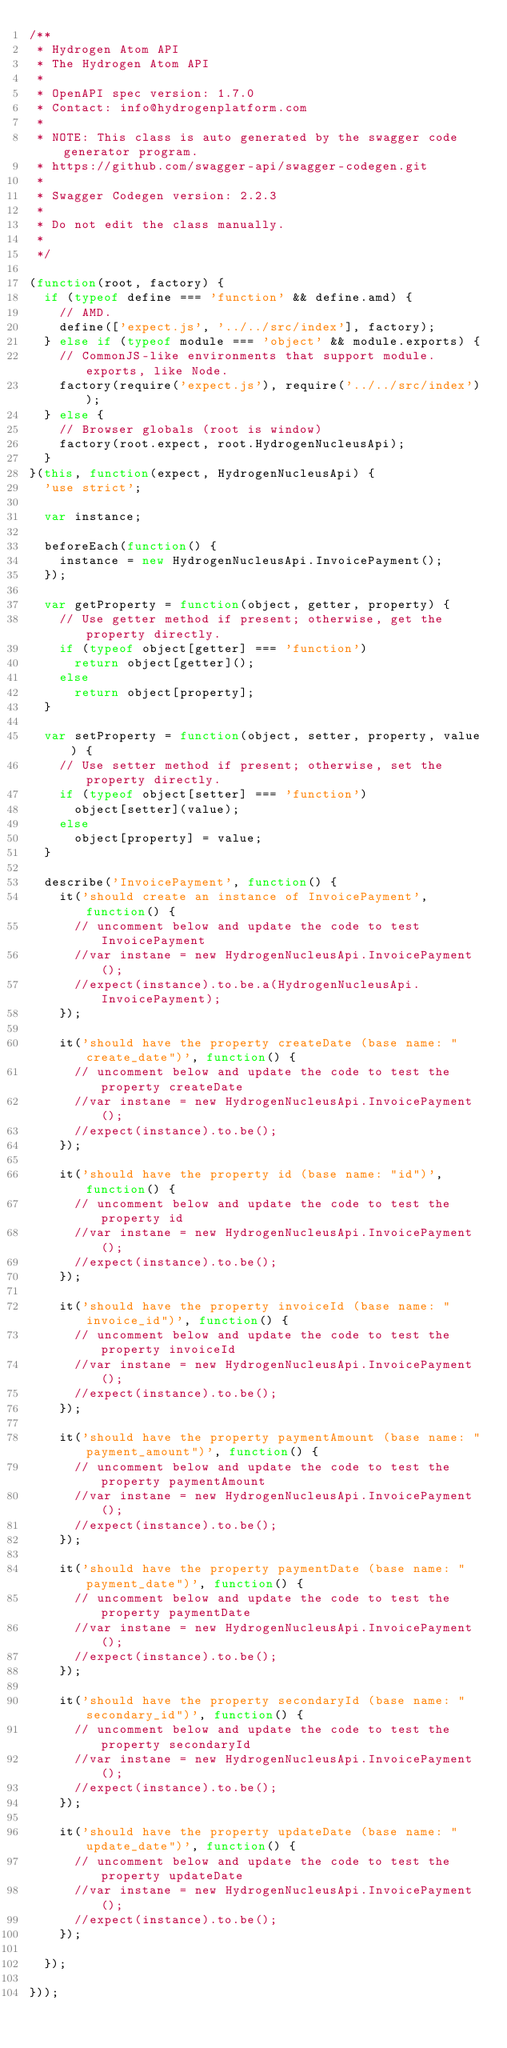<code> <loc_0><loc_0><loc_500><loc_500><_JavaScript_>/**
 * Hydrogen Atom API
 * The Hydrogen Atom API
 *
 * OpenAPI spec version: 1.7.0
 * Contact: info@hydrogenplatform.com
 *
 * NOTE: This class is auto generated by the swagger code generator program.
 * https://github.com/swagger-api/swagger-codegen.git
 *
 * Swagger Codegen version: 2.2.3
 *
 * Do not edit the class manually.
 *
 */

(function(root, factory) {
  if (typeof define === 'function' && define.amd) {
    // AMD.
    define(['expect.js', '../../src/index'], factory);
  } else if (typeof module === 'object' && module.exports) {
    // CommonJS-like environments that support module.exports, like Node.
    factory(require('expect.js'), require('../../src/index'));
  } else {
    // Browser globals (root is window)
    factory(root.expect, root.HydrogenNucleusApi);
  }
}(this, function(expect, HydrogenNucleusApi) {
  'use strict';

  var instance;

  beforeEach(function() {
    instance = new HydrogenNucleusApi.InvoicePayment();
  });

  var getProperty = function(object, getter, property) {
    // Use getter method if present; otherwise, get the property directly.
    if (typeof object[getter] === 'function')
      return object[getter]();
    else
      return object[property];
  }

  var setProperty = function(object, setter, property, value) {
    // Use setter method if present; otherwise, set the property directly.
    if (typeof object[setter] === 'function')
      object[setter](value);
    else
      object[property] = value;
  }

  describe('InvoicePayment', function() {
    it('should create an instance of InvoicePayment', function() {
      // uncomment below and update the code to test InvoicePayment
      //var instane = new HydrogenNucleusApi.InvoicePayment();
      //expect(instance).to.be.a(HydrogenNucleusApi.InvoicePayment);
    });

    it('should have the property createDate (base name: "create_date")', function() {
      // uncomment below and update the code to test the property createDate
      //var instane = new HydrogenNucleusApi.InvoicePayment();
      //expect(instance).to.be();
    });

    it('should have the property id (base name: "id")', function() {
      // uncomment below and update the code to test the property id
      //var instane = new HydrogenNucleusApi.InvoicePayment();
      //expect(instance).to.be();
    });

    it('should have the property invoiceId (base name: "invoice_id")', function() {
      // uncomment below and update the code to test the property invoiceId
      //var instane = new HydrogenNucleusApi.InvoicePayment();
      //expect(instance).to.be();
    });

    it('should have the property paymentAmount (base name: "payment_amount")', function() {
      // uncomment below and update the code to test the property paymentAmount
      //var instane = new HydrogenNucleusApi.InvoicePayment();
      //expect(instance).to.be();
    });

    it('should have the property paymentDate (base name: "payment_date")', function() {
      // uncomment below and update the code to test the property paymentDate
      //var instane = new HydrogenNucleusApi.InvoicePayment();
      //expect(instance).to.be();
    });

    it('should have the property secondaryId (base name: "secondary_id")', function() {
      // uncomment below and update the code to test the property secondaryId
      //var instane = new HydrogenNucleusApi.InvoicePayment();
      //expect(instance).to.be();
    });

    it('should have the property updateDate (base name: "update_date")', function() {
      // uncomment below and update the code to test the property updateDate
      //var instane = new HydrogenNucleusApi.InvoicePayment();
      //expect(instance).to.be();
    });

  });

}));
</code> 